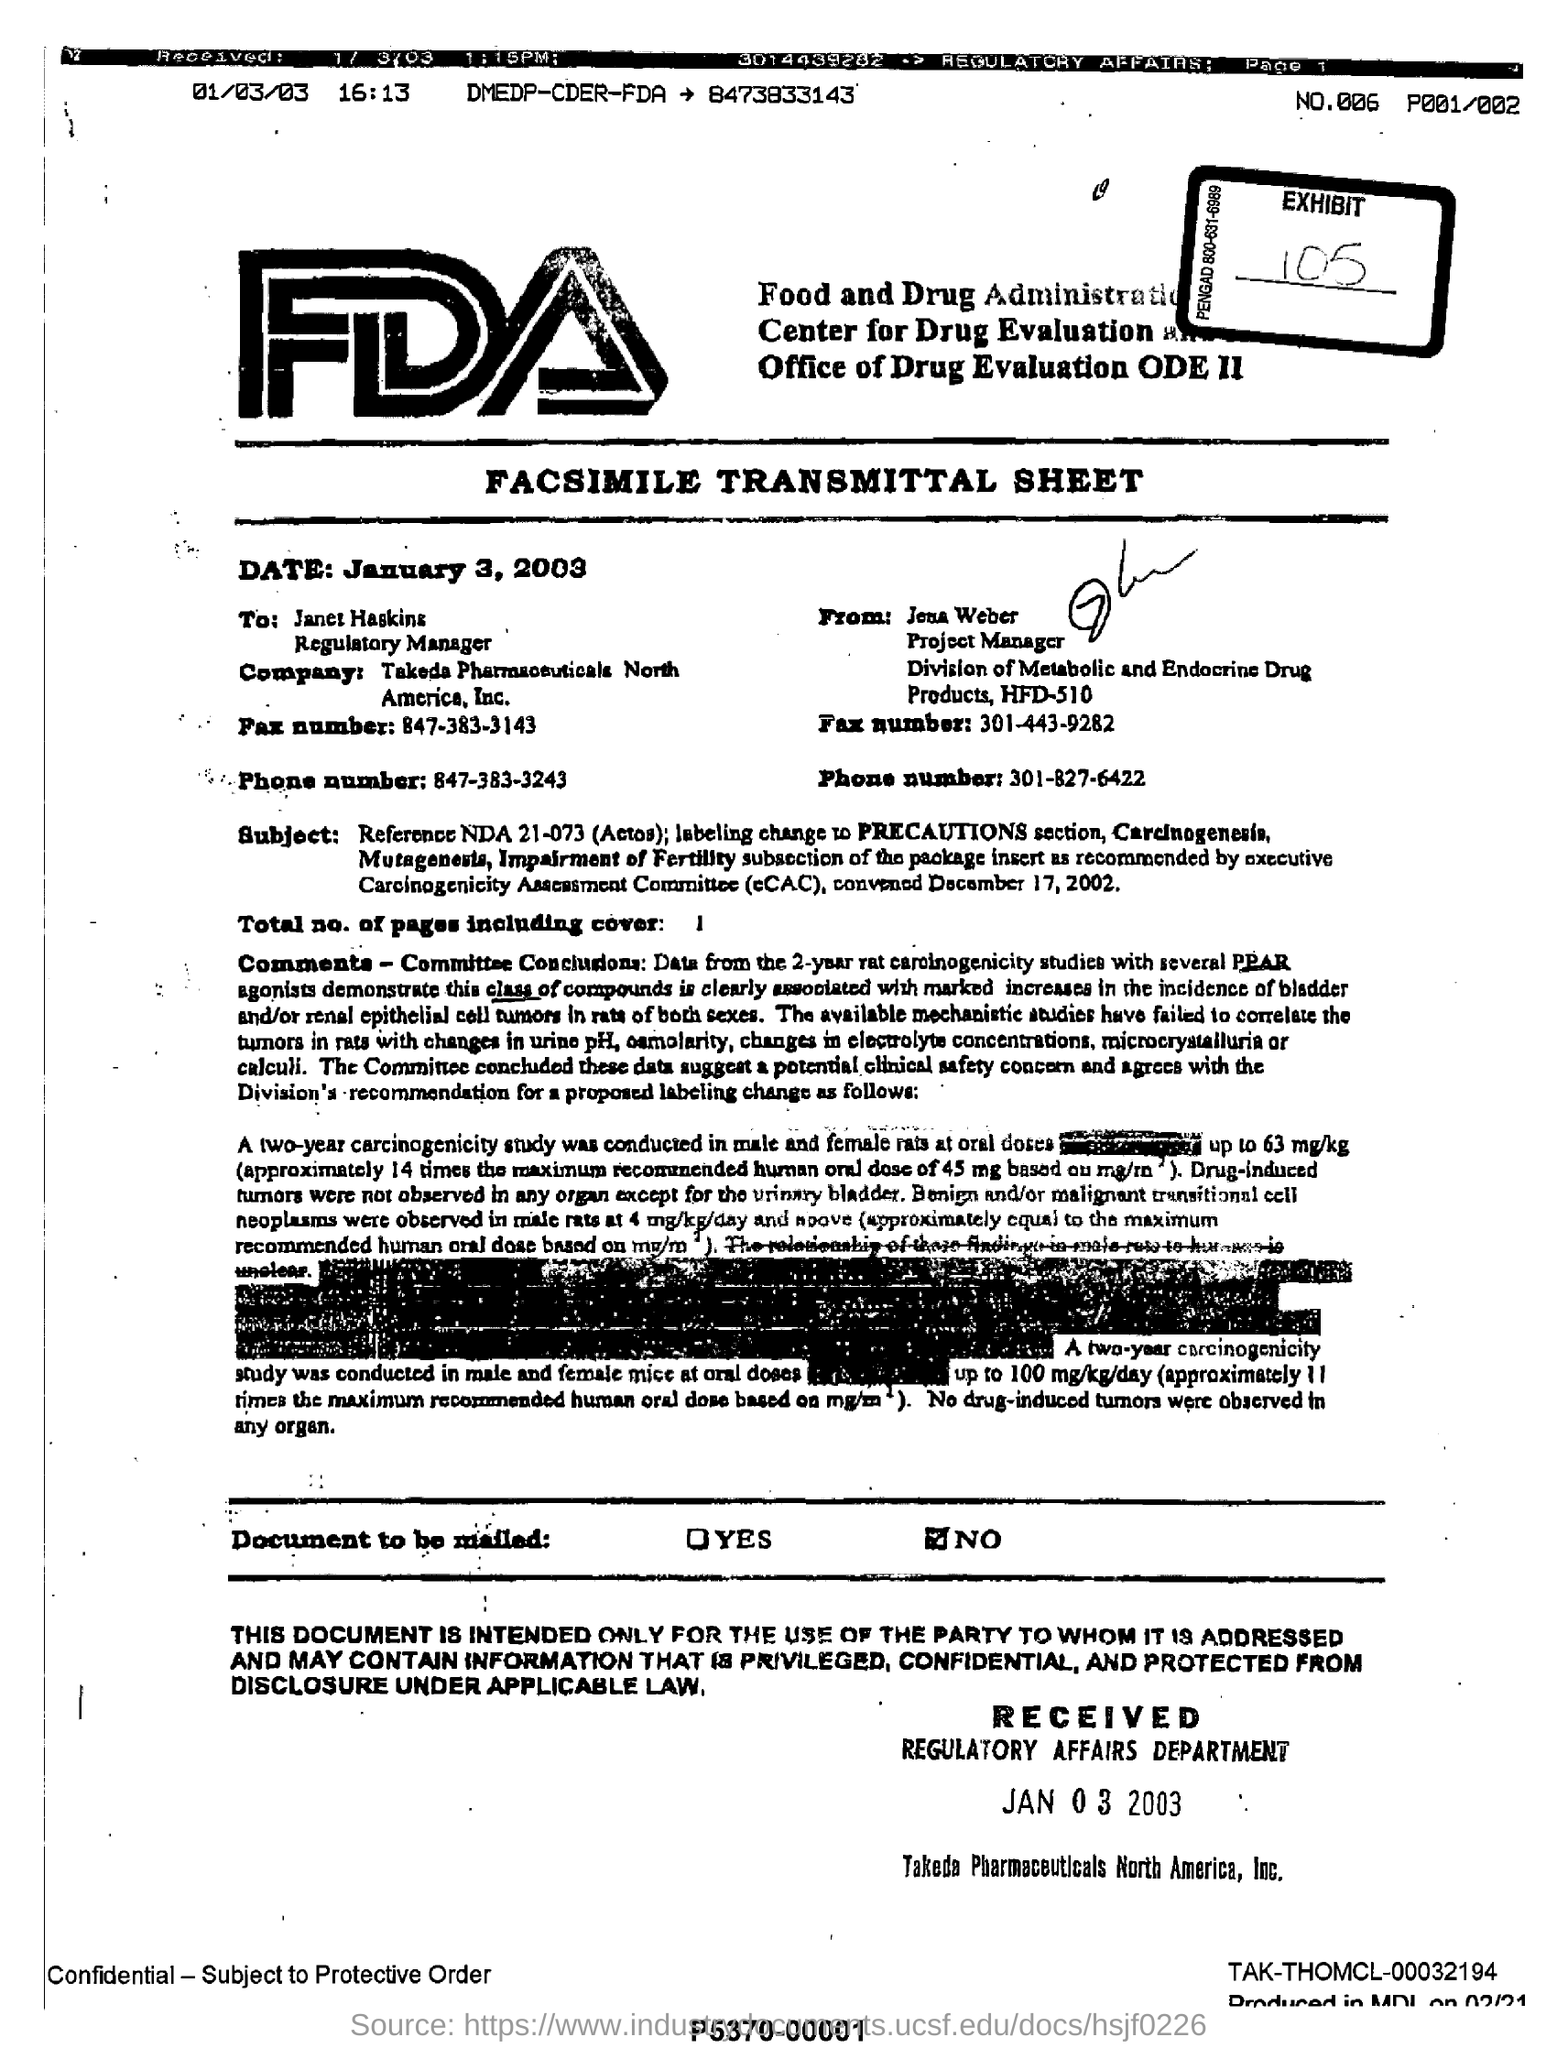What is the full form of FDA?
Ensure brevity in your answer.  Food and Drug Administration. What is the date mentioned?
Offer a very short reply. January 3, 2003. Who is the sender of this fax?
Your response must be concise. Jena Weber. What is the total no of pages in the fax including cover?
Provide a succinct answer. 1. 